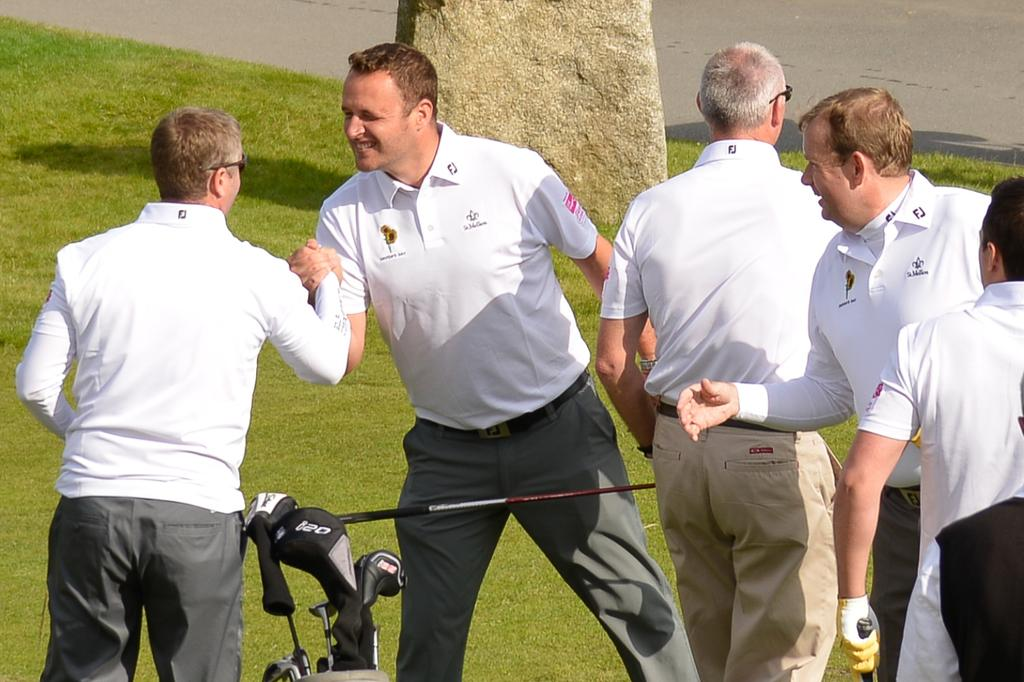What are the men in the image wearing? The men are wearing white t-shirts and white pants. What objects can be seen in the image that are associated with a sport? Golf sticks are visible in the image. What type of surface is present in the image? There is grass in the image. Can you describe any visual effect in the image? There is a shadow in the image. What type of yam is being measured by the men in the image? There is no yam present in the image; the men are wearing white t-shirts and white pants, and there are golf sticks visible. What historical event is depicted in the image? There is no specific historical event depicted in the image; it shows men wearing white clothing and holding golf sticks on a grassy surface. 